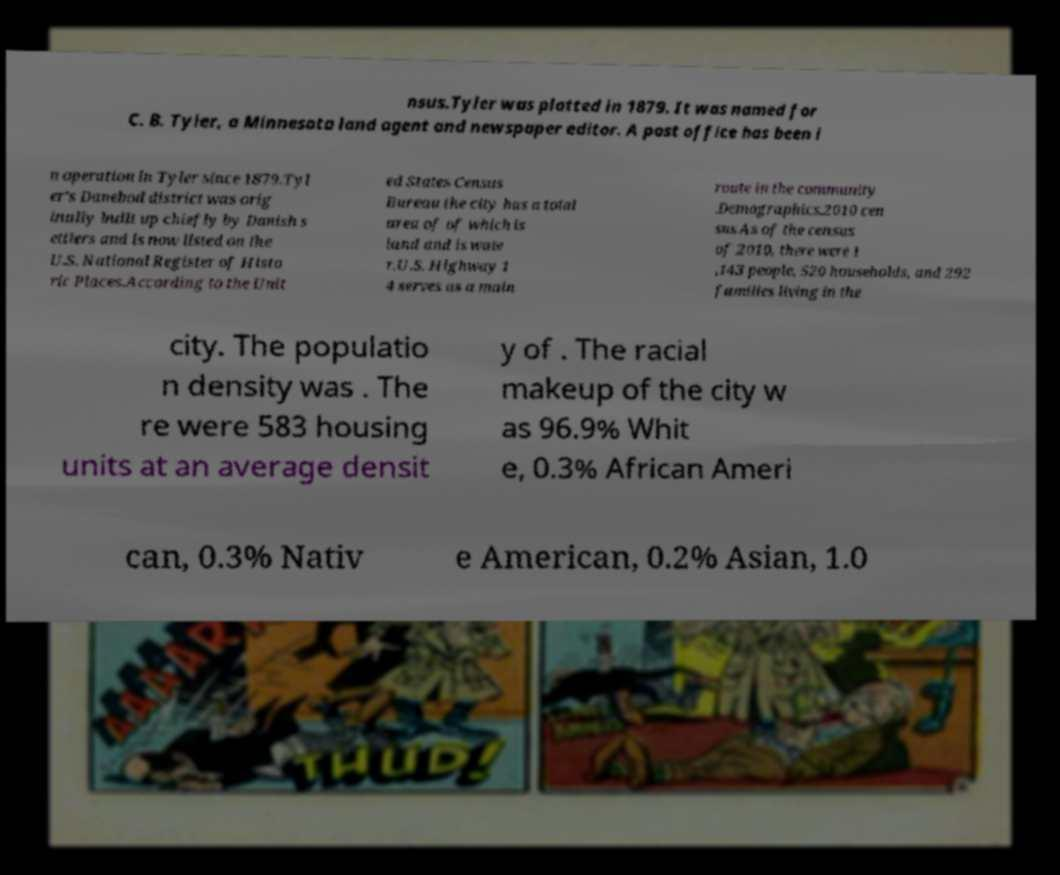What messages or text are displayed in this image? I need them in a readable, typed format. nsus.Tyler was platted in 1879. It was named for C. B. Tyler, a Minnesota land agent and newspaper editor. A post office has been i n operation in Tyler since 1879.Tyl er's Danebod district was orig inally built up chiefly by Danish s ettlers and is now listed on the U.S. National Register of Histo ric Places.According to the Unit ed States Census Bureau the city has a total area of of which is land and is wate r.U.S. Highway 1 4 serves as a main route in the community .Demographics.2010 cen sus.As of the census of 2010, there were 1 ,143 people, 520 households, and 292 families living in the city. The populatio n density was . The re were 583 housing units at an average densit y of . The racial makeup of the city w as 96.9% Whit e, 0.3% African Ameri can, 0.3% Nativ e American, 0.2% Asian, 1.0 